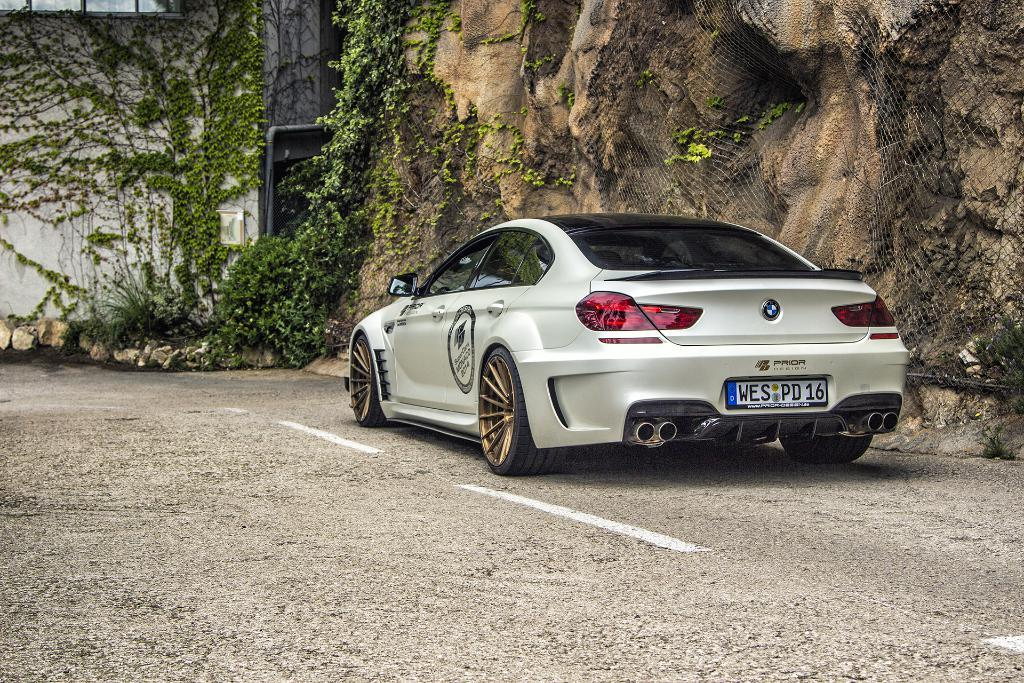What is parked in the image? There is a car parked in the image. What celestial bodies can be seen in the image? There are planets visible in the image. What is in the background of the image? There is a wall in the background of the image. What type of sweater is the car wearing in the image? Cars do not wear sweaters, as they are inanimate objects. The car in the image is not wearing any clothing. 